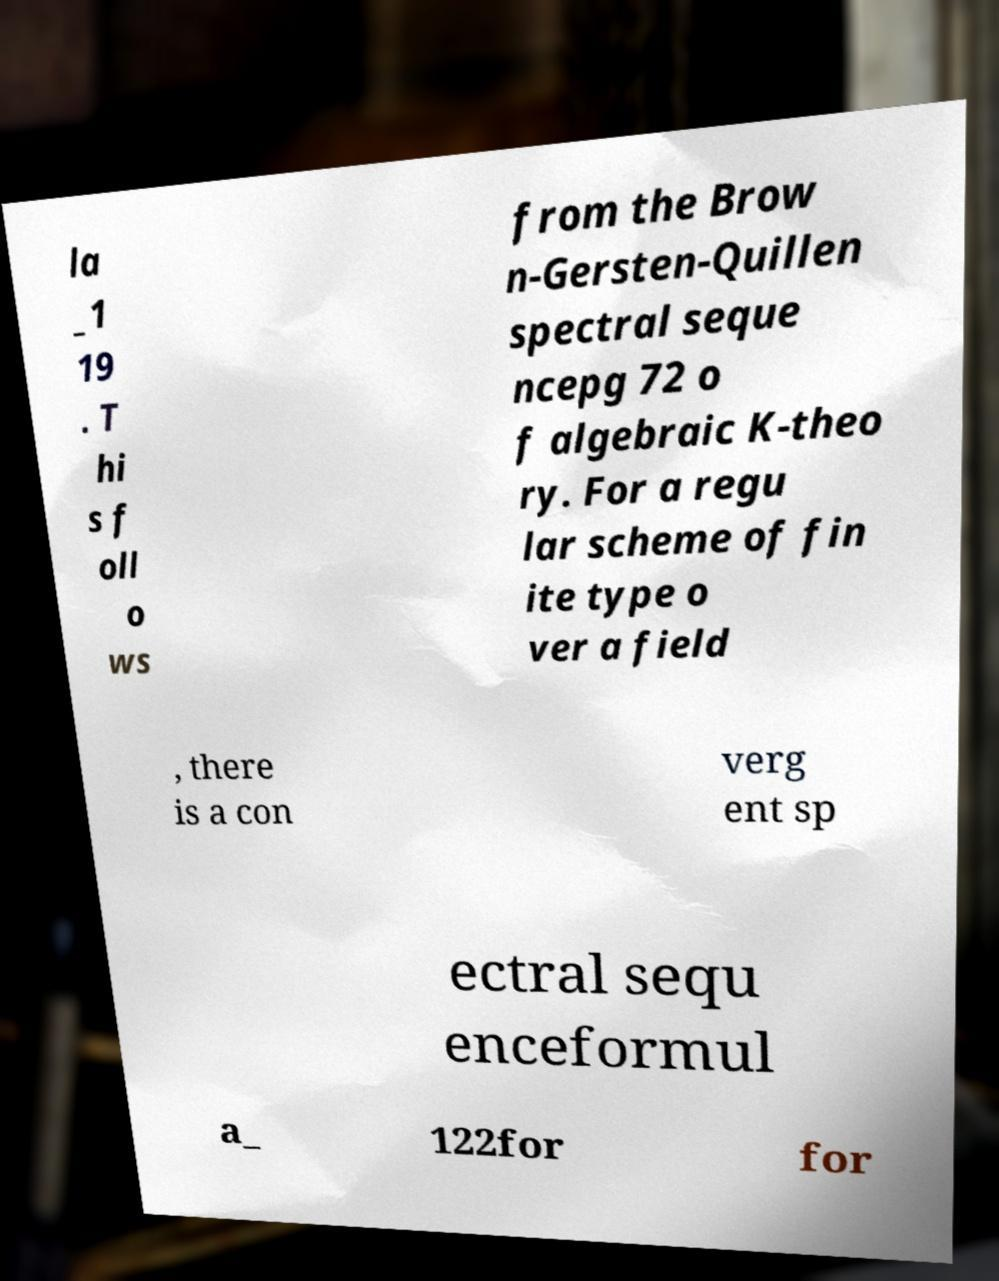What messages or text are displayed in this image? I need them in a readable, typed format. la _1 19 . T hi s f oll o ws from the Brow n-Gersten-Quillen spectral seque ncepg 72 o f algebraic K-theo ry. For a regu lar scheme of fin ite type o ver a field , there is a con verg ent sp ectral sequ enceformul a_ 122for for 